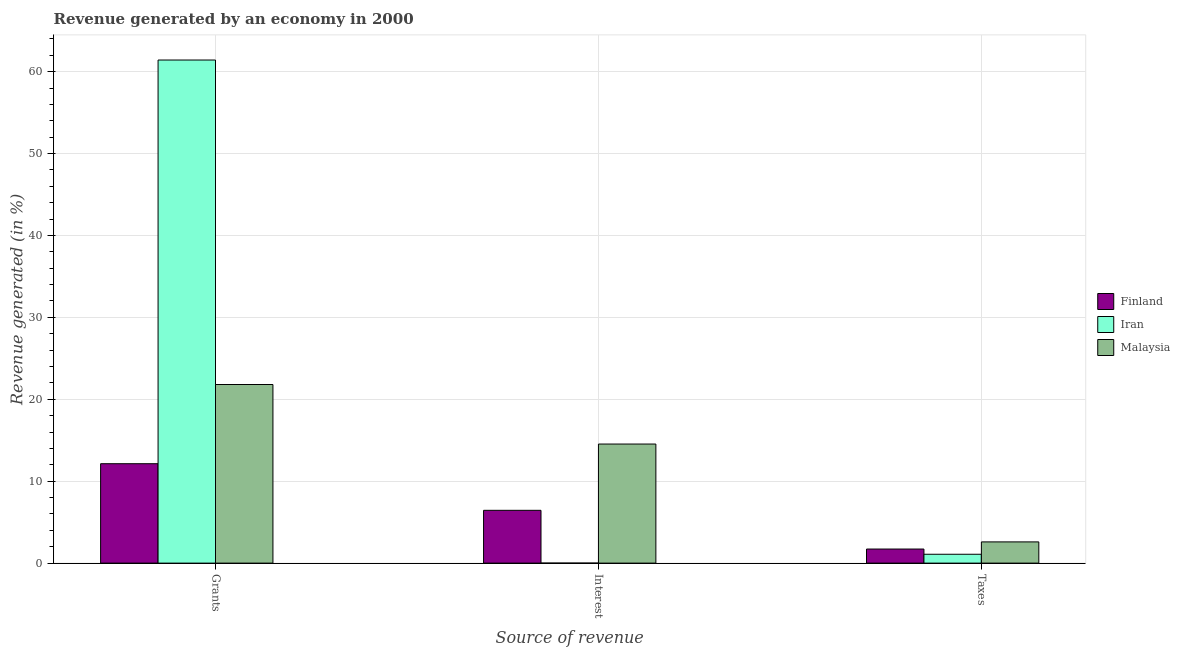How many different coloured bars are there?
Provide a succinct answer. 3. How many groups of bars are there?
Keep it short and to the point. 3. Are the number of bars per tick equal to the number of legend labels?
Your answer should be compact. Yes. Are the number of bars on each tick of the X-axis equal?
Offer a terse response. Yes. How many bars are there on the 2nd tick from the right?
Provide a succinct answer. 3. What is the label of the 3rd group of bars from the left?
Offer a very short reply. Taxes. What is the percentage of revenue generated by taxes in Iran?
Make the answer very short. 1.08. Across all countries, what is the maximum percentage of revenue generated by taxes?
Make the answer very short. 2.59. Across all countries, what is the minimum percentage of revenue generated by interest?
Your answer should be compact. 5.52099100195348e-5. In which country was the percentage of revenue generated by grants maximum?
Your response must be concise. Iran. In which country was the percentage of revenue generated by taxes minimum?
Ensure brevity in your answer.  Iran. What is the total percentage of revenue generated by grants in the graph?
Your response must be concise. 95.36. What is the difference between the percentage of revenue generated by grants in Finland and that in Iran?
Offer a terse response. -49.28. What is the difference between the percentage of revenue generated by interest in Malaysia and the percentage of revenue generated by grants in Iran?
Your answer should be very brief. -46.88. What is the average percentage of revenue generated by interest per country?
Offer a terse response. 6.99. What is the difference between the percentage of revenue generated by interest and percentage of revenue generated by taxes in Malaysia?
Your answer should be very brief. 11.95. In how many countries, is the percentage of revenue generated by grants greater than 26 %?
Make the answer very short. 1. What is the ratio of the percentage of revenue generated by grants in Finland to that in Iran?
Your response must be concise. 0.2. What is the difference between the highest and the second highest percentage of revenue generated by interest?
Offer a very short reply. 8.09. What is the difference between the highest and the lowest percentage of revenue generated by taxes?
Offer a very short reply. 1.51. Is the sum of the percentage of revenue generated by grants in Malaysia and Iran greater than the maximum percentage of revenue generated by interest across all countries?
Offer a terse response. Yes. What does the 2nd bar from the left in Grants represents?
Make the answer very short. Iran. What does the 3rd bar from the right in Taxes represents?
Ensure brevity in your answer.  Finland. What is the difference between two consecutive major ticks on the Y-axis?
Offer a very short reply. 10. Does the graph contain grids?
Offer a very short reply. Yes. How many legend labels are there?
Provide a succinct answer. 3. How are the legend labels stacked?
Offer a very short reply. Vertical. What is the title of the graph?
Your answer should be compact. Revenue generated by an economy in 2000. What is the label or title of the X-axis?
Make the answer very short. Source of revenue. What is the label or title of the Y-axis?
Offer a very short reply. Revenue generated (in %). What is the Revenue generated (in %) in Finland in Grants?
Give a very brief answer. 12.13. What is the Revenue generated (in %) of Iran in Grants?
Ensure brevity in your answer.  61.42. What is the Revenue generated (in %) in Malaysia in Grants?
Make the answer very short. 21.8. What is the Revenue generated (in %) of Finland in Interest?
Provide a short and direct response. 6.45. What is the Revenue generated (in %) in Iran in Interest?
Keep it short and to the point. 5.52099100195348e-5. What is the Revenue generated (in %) of Malaysia in Interest?
Ensure brevity in your answer.  14.54. What is the Revenue generated (in %) of Finland in Taxes?
Provide a short and direct response. 1.72. What is the Revenue generated (in %) in Iran in Taxes?
Offer a very short reply. 1.08. What is the Revenue generated (in %) in Malaysia in Taxes?
Make the answer very short. 2.59. Across all Source of revenue, what is the maximum Revenue generated (in %) in Finland?
Provide a short and direct response. 12.13. Across all Source of revenue, what is the maximum Revenue generated (in %) in Iran?
Provide a succinct answer. 61.42. Across all Source of revenue, what is the maximum Revenue generated (in %) of Malaysia?
Ensure brevity in your answer.  21.8. Across all Source of revenue, what is the minimum Revenue generated (in %) of Finland?
Make the answer very short. 1.72. Across all Source of revenue, what is the minimum Revenue generated (in %) in Iran?
Keep it short and to the point. 5.52099100195348e-5. Across all Source of revenue, what is the minimum Revenue generated (in %) of Malaysia?
Keep it short and to the point. 2.59. What is the total Revenue generated (in %) of Finland in the graph?
Ensure brevity in your answer.  20.3. What is the total Revenue generated (in %) in Iran in the graph?
Make the answer very short. 62.5. What is the total Revenue generated (in %) in Malaysia in the graph?
Give a very brief answer. 38.93. What is the difference between the Revenue generated (in %) of Finland in Grants and that in Interest?
Your response must be concise. 5.69. What is the difference between the Revenue generated (in %) of Iran in Grants and that in Interest?
Your response must be concise. 61.42. What is the difference between the Revenue generated (in %) of Malaysia in Grants and that in Interest?
Give a very brief answer. 7.27. What is the difference between the Revenue generated (in %) in Finland in Grants and that in Taxes?
Provide a short and direct response. 10.42. What is the difference between the Revenue generated (in %) of Iran in Grants and that in Taxes?
Keep it short and to the point. 60.33. What is the difference between the Revenue generated (in %) of Malaysia in Grants and that in Taxes?
Give a very brief answer. 19.21. What is the difference between the Revenue generated (in %) in Finland in Interest and that in Taxes?
Provide a succinct answer. 4.73. What is the difference between the Revenue generated (in %) in Iran in Interest and that in Taxes?
Keep it short and to the point. -1.08. What is the difference between the Revenue generated (in %) of Malaysia in Interest and that in Taxes?
Give a very brief answer. 11.95. What is the difference between the Revenue generated (in %) of Finland in Grants and the Revenue generated (in %) of Iran in Interest?
Your answer should be compact. 12.13. What is the difference between the Revenue generated (in %) of Finland in Grants and the Revenue generated (in %) of Malaysia in Interest?
Provide a short and direct response. -2.4. What is the difference between the Revenue generated (in %) of Iran in Grants and the Revenue generated (in %) of Malaysia in Interest?
Offer a terse response. 46.88. What is the difference between the Revenue generated (in %) of Finland in Grants and the Revenue generated (in %) of Iran in Taxes?
Your response must be concise. 11.05. What is the difference between the Revenue generated (in %) in Finland in Grants and the Revenue generated (in %) in Malaysia in Taxes?
Offer a very short reply. 9.55. What is the difference between the Revenue generated (in %) of Iran in Grants and the Revenue generated (in %) of Malaysia in Taxes?
Ensure brevity in your answer.  58.83. What is the difference between the Revenue generated (in %) in Finland in Interest and the Revenue generated (in %) in Iran in Taxes?
Provide a short and direct response. 5.36. What is the difference between the Revenue generated (in %) of Finland in Interest and the Revenue generated (in %) of Malaysia in Taxes?
Give a very brief answer. 3.86. What is the difference between the Revenue generated (in %) of Iran in Interest and the Revenue generated (in %) of Malaysia in Taxes?
Keep it short and to the point. -2.59. What is the average Revenue generated (in %) in Finland per Source of revenue?
Offer a terse response. 6.77. What is the average Revenue generated (in %) of Iran per Source of revenue?
Your answer should be very brief. 20.83. What is the average Revenue generated (in %) of Malaysia per Source of revenue?
Offer a terse response. 12.98. What is the difference between the Revenue generated (in %) in Finland and Revenue generated (in %) in Iran in Grants?
Give a very brief answer. -49.28. What is the difference between the Revenue generated (in %) of Finland and Revenue generated (in %) of Malaysia in Grants?
Your response must be concise. -9.67. What is the difference between the Revenue generated (in %) in Iran and Revenue generated (in %) in Malaysia in Grants?
Provide a succinct answer. 39.61. What is the difference between the Revenue generated (in %) of Finland and Revenue generated (in %) of Iran in Interest?
Ensure brevity in your answer.  6.45. What is the difference between the Revenue generated (in %) of Finland and Revenue generated (in %) of Malaysia in Interest?
Provide a short and direct response. -8.09. What is the difference between the Revenue generated (in %) in Iran and Revenue generated (in %) in Malaysia in Interest?
Your answer should be very brief. -14.54. What is the difference between the Revenue generated (in %) of Finland and Revenue generated (in %) of Iran in Taxes?
Keep it short and to the point. 0.64. What is the difference between the Revenue generated (in %) in Finland and Revenue generated (in %) in Malaysia in Taxes?
Offer a very short reply. -0.87. What is the difference between the Revenue generated (in %) in Iran and Revenue generated (in %) in Malaysia in Taxes?
Give a very brief answer. -1.51. What is the ratio of the Revenue generated (in %) of Finland in Grants to that in Interest?
Your response must be concise. 1.88. What is the ratio of the Revenue generated (in %) in Iran in Grants to that in Interest?
Give a very brief answer. 1.11e+06. What is the ratio of the Revenue generated (in %) in Malaysia in Grants to that in Interest?
Your answer should be very brief. 1.5. What is the ratio of the Revenue generated (in %) of Finland in Grants to that in Taxes?
Your answer should be compact. 7.06. What is the ratio of the Revenue generated (in %) in Iran in Grants to that in Taxes?
Keep it short and to the point. 56.76. What is the ratio of the Revenue generated (in %) in Malaysia in Grants to that in Taxes?
Provide a succinct answer. 8.42. What is the ratio of the Revenue generated (in %) in Finland in Interest to that in Taxes?
Provide a succinct answer. 3.75. What is the ratio of the Revenue generated (in %) in Iran in Interest to that in Taxes?
Ensure brevity in your answer.  0. What is the ratio of the Revenue generated (in %) of Malaysia in Interest to that in Taxes?
Your response must be concise. 5.61. What is the difference between the highest and the second highest Revenue generated (in %) of Finland?
Make the answer very short. 5.69. What is the difference between the highest and the second highest Revenue generated (in %) in Iran?
Keep it short and to the point. 60.33. What is the difference between the highest and the second highest Revenue generated (in %) of Malaysia?
Offer a terse response. 7.27. What is the difference between the highest and the lowest Revenue generated (in %) in Finland?
Offer a very short reply. 10.42. What is the difference between the highest and the lowest Revenue generated (in %) in Iran?
Make the answer very short. 61.42. What is the difference between the highest and the lowest Revenue generated (in %) of Malaysia?
Provide a short and direct response. 19.21. 